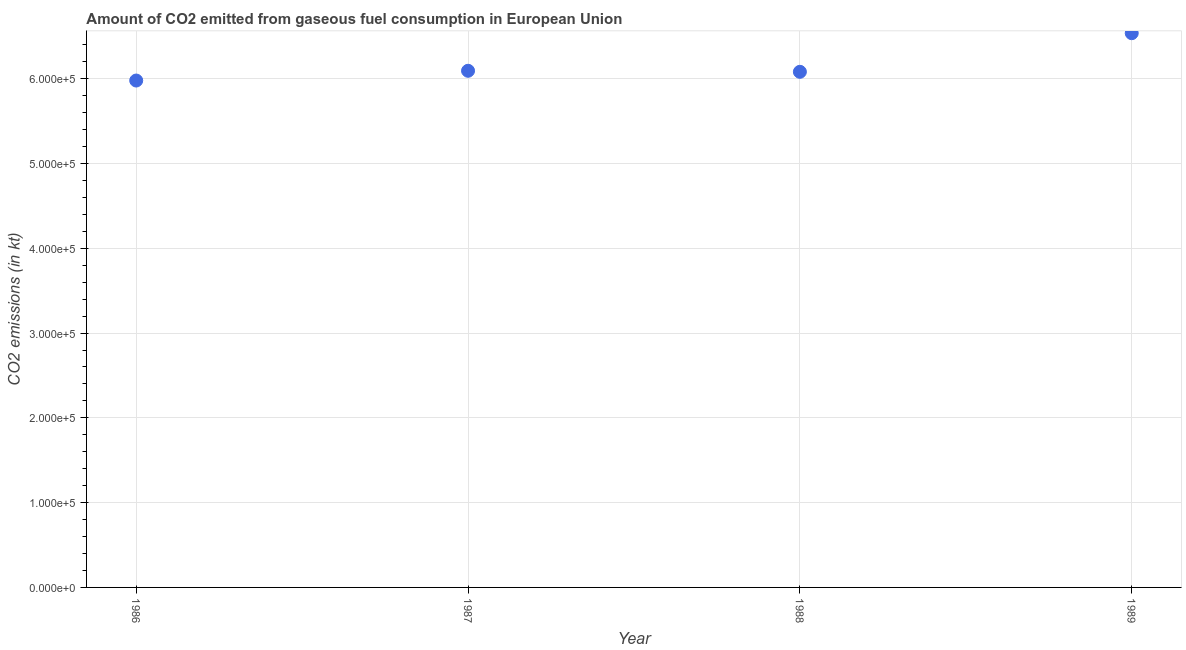What is the co2 emissions from gaseous fuel consumption in 1988?
Make the answer very short. 6.08e+05. Across all years, what is the maximum co2 emissions from gaseous fuel consumption?
Your response must be concise. 6.54e+05. Across all years, what is the minimum co2 emissions from gaseous fuel consumption?
Give a very brief answer. 5.98e+05. What is the sum of the co2 emissions from gaseous fuel consumption?
Offer a terse response. 2.47e+06. What is the difference between the co2 emissions from gaseous fuel consumption in 1986 and 1988?
Offer a very short reply. -1.03e+04. What is the average co2 emissions from gaseous fuel consumption per year?
Keep it short and to the point. 6.17e+05. What is the median co2 emissions from gaseous fuel consumption?
Provide a short and direct response. 6.09e+05. Do a majority of the years between 1986 and 1989 (inclusive) have co2 emissions from gaseous fuel consumption greater than 420000 kt?
Your response must be concise. Yes. What is the ratio of the co2 emissions from gaseous fuel consumption in 1986 to that in 1987?
Ensure brevity in your answer.  0.98. Is the co2 emissions from gaseous fuel consumption in 1987 less than that in 1989?
Provide a short and direct response. Yes. What is the difference between the highest and the second highest co2 emissions from gaseous fuel consumption?
Your answer should be compact. 4.43e+04. Is the sum of the co2 emissions from gaseous fuel consumption in 1986 and 1989 greater than the maximum co2 emissions from gaseous fuel consumption across all years?
Make the answer very short. Yes. What is the difference between the highest and the lowest co2 emissions from gaseous fuel consumption?
Offer a very short reply. 5.58e+04. What is the title of the graph?
Make the answer very short. Amount of CO2 emitted from gaseous fuel consumption in European Union. What is the label or title of the X-axis?
Ensure brevity in your answer.  Year. What is the label or title of the Y-axis?
Provide a succinct answer. CO2 emissions (in kt). What is the CO2 emissions (in kt) in 1986?
Keep it short and to the point. 5.98e+05. What is the CO2 emissions (in kt) in 1987?
Your answer should be compact. 6.09e+05. What is the CO2 emissions (in kt) in 1988?
Ensure brevity in your answer.  6.08e+05. What is the CO2 emissions (in kt) in 1989?
Provide a short and direct response. 6.54e+05. What is the difference between the CO2 emissions (in kt) in 1986 and 1987?
Your response must be concise. -1.15e+04. What is the difference between the CO2 emissions (in kt) in 1986 and 1988?
Give a very brief answer. -1.03e+04. What is the difference between the CO2 emissions (in kt) in 1986 and 1989?
Offer a very short reply. -5.58e+04. What is the difference between the CO2 emissions (in kt) in 1987 and 1988?
Offer a terse response. 1218.99. What is the difference between the CO2 emissions (in kt) in 1987 and 1989?
Offer a terse response. -4.43e+04. What is the difference between the CO2 emissions (in kt) in 1988 and 1989?
Offer a very short reply. -4.56e+04. What is the ratio of the CO2 emissions (in kt) in 1986 to that in 1987?
Provide a short and direct response. 0.98. What is the ratio of the CO2 emissions (in kt) in 1986 to that in 1989?
Your answer should be compact. 0.92. What is the ratio of the CO2 emissions (in kt) in 1987 to that in 1988?
Your answer should be very brief. 1. What is the ratio of the CO2 emissions (in kt) in 1987 to that in 1989?
Keep it short and to the point. 0.93. 